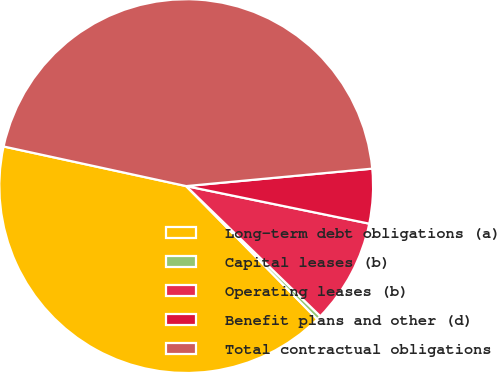<chart> <loc_0><loc_0><loc_500><loc_500><pie_chart><fcel>Long-term debt obligations (a)<fcel>Capital leases (b)<fcel>Operating leases (b)<fcel>Benefit plans and other (d)<fcel>Total contractual obligations<nl><fcel>40.77%<fcel>0.37%<fcel>9.04%<fcel>4.71%<fcel>45.11%<nl></chart> 